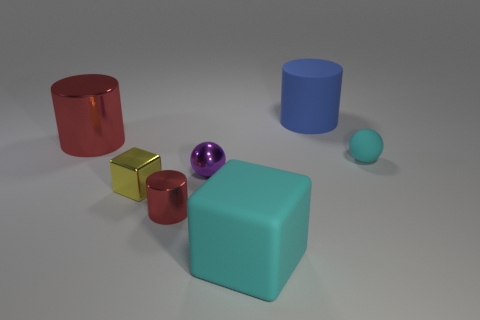Which objects in the image could neatly stack on top of one another? The two red cylinders could stack on one another, as could the two cubes, with the smaller gold cube sitting atop the larger teal one. 